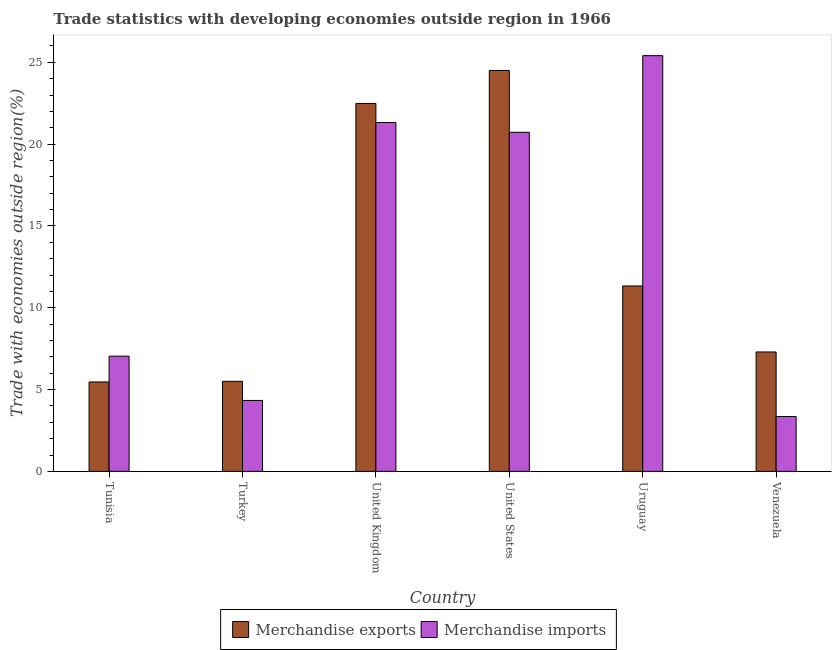How many groups of bars are there?
Your answer should be very brief. 6. How many bars are there on the 1st tick from the left?
Your response must be concise. 2. How many bars are there on the 5th tick from the right?
Your answer should be very brief. 2. What is the label of the 5th group of bars from the left?
Offer a terse response. Uruguay. What is the merchandise imports in Uruguay?
Your answer should be compact. 25.41. Across all countries, what is the maximum merchandise imports?
Offer a very short reply. 25.41. Across all countries, what is the minimum merchandise exports?
Make the answer very short. 5.46. In which country was the merchandise imports maximum?
Offer a terse response. Uruguay. In which country was the merchandise imports minimum?
Offer a very short reply. Venezuela. What is the total merchandise imports in the graph?
Your answer should be very brief. 82.18. What is the difference between the merchandise imports in Tunisia and that in Turkey?
Keep it short and to the point. 2.71. What is the difference between the merchandise exports in United Kingdom and the merchandise imports in Tunisia?
Keep it short and to the point. 15.45. What is the average merchandise imports per country?
Make the answer very short. 13.7. What is the difference between the merchandise imports and merchandise exports in Uruguay?
Offer a very short reply. 14.08. In how many countries, is the merchandise exports greater than 9 %?
Your answer should be very brief. 3. What is the ratio of the merchandise exports in United States to that in Venezuela?
Offer a terse response. 3.36. Is the merchandise exports in Tunisia less than that in United States?
Your answer should be compact. Yes. What is the difference between the highest and the second highest merchandise imports?
Provide a short and direct response. 4.09. What is the difference between the highest and the lowest merchandise imports?
Offer a terse response. 22.06. In how many countries, is the merchandise imports greater than the average merchandise imports taken over all countries?
Offer a terse response. 3. What does the 1st bar from the right in United Kingdom represents?
Offer a terse response. Merchandise imports. Are the values on the major ticks of Y-axis written in scientific E-notation?
Offer a terse response. No. Does the graph contain any zero values?
Ensure brevity in your answer.  No. Does the graph contain grids?
Provide a succinct answer. No. How many legend labels are there?
Make the answer very short. 2. How are the legend labels stacked?
Make the answer very short. Horizontal. What is the title of the graph?
Make the answer very short. Trade statistics with developing economies outside region in 1966. What is the label or title of the X-axis?
Your answer should be very brief. Country. What is the label or title of the Y-axis?
Provide a succinct answer. Trade with economies outside region(%). What is the Trade with economies outside region(%) of Merchandise exports in Tunisia?
Keep it short and to the point. 5.46. What is the Trade with economies outside region(%) in Merchandise imports in Tunisia?
Ensure brevity in your answer.  7.04. What is the Trade with economies outside region(%) of Merchandise exports in Turkey?
Your answer should be compact. 5.5. What is the Trade with economies outside region(%) of Merchandise imports in Turkey?
Provide a succinct answer. 4.34. What is the Trade with economies outside region(%) in Merchandise exports in United Kingdom?
Make the answer very short. 22.49. What is the Trade with economies outside region(%) of Merchandise imports in United Kingdom?
Offer a terse response. 21.32. What is the Trade with economies outside region(%) in Merchandise exports in United States?
Your answer should be compact. 24.51. What is the Trade with economies outside region(%) in Merchandise imports in United States?
Give a very brief answer. 20.73. What is the Trade with economies outside region(%) of Merchandise exports in Uruguay?
Offer a terse response. 11.33. What is the Trade with economies outside region(%) in Merchandise imports in Uruguay?
Your answer should be compact. 25.41. What is the Trade with economies outside region(%) of Merchandise exports in Venezuela?
Your answer should be very brief. 7.3. What is the Trade with economies outside region(%) in Merchandise imports in Venezuela?
Ensure brevity in your answer.  3.35. Across all countries, what is the maximum Trade with economies outside region(%) in Merchandise exports?
Your response must be concise. 24.51. Across all countries, what is the maximum Trade with economies outside region(%) in Merchandise imports?
Offer a very short reply. 25.41. Across all countries, what is the minimum Trade with economies outside region(%) in Merchandise exports?
Your answer should be compact. 5.46. Across all countries, what is the minimum Trade with economies outside region(%) in Merchandise imports?
Offer a terse response. 3.35. What is the total Trade with economies outside region(%) in Merchandise exports in the graph?
Give a very brief answer. 76.59. What is the total Trade with economies outside region(%) in Merchandise imports in the graph?
Keep it short and to the point. 82.18. What is the difference between the Trade with economies outside region(%) of Merchandise exports in Tunisia and that in Turkey?
Offer a terse response. -0.04. What is the difference between the Trade with economies outside region(%) in Merchandise imports in Tunisia and that in Turkey?
Your answer should be very brief. 2.71. What is the difference between the Trade with economies outside region(%) in Merchandise exports in Tunisia and that in United Kingdom?
Give a very brief answer. -17.02. What is the difference between the Trade with economies outside region(%) in Merchandise imports in Tunisia and that in United Kingdom?
Provide a short and direct response. -14.28. What is the difference between the Trade with economies outside region(%) of Merchandise exports in Tunisia and that in United States?
Provide a short and direct response. -19.04. What is the difference between the Trade with economies outside region(%) in Merchandise imports in Tunisia and that in United States?
Ensure brevity in your answer.  -13.68. What is the difference between the Trade with economies outside region(%) in Merchandise exports in Tunisia and that in Uruguay?
Provide a short and direct response. -5.87. What is the difference between the Trade with economies outside region(%) of Merchandise imports in Tunisia and that in Uruguay?
Give a very brief answer. -18.37. What is the difference between the Trade with economies outside region(%) in Merchandise exports in Tunisia and that in Venezuela?
Offer a terse response. -1.83. What is the difference between the Trade with economies outside region(%) of Merchandise imports in Tunisia and that in Venezuela?
Keep it short and to the point. 3.69. What is the difference between the Trade with economies outside region(%) of Merchandise exports in Turkey and that in United Kingdom?
Give a very brief answer. -16.99. What is the difference between the Trade with economies outside region(%) of Merchandise imports in Turkey and that in United Kingdom?
Keep it short and to the point. -16.99. What is the difference between the Trade with economies outside region(%) of Merchandise exports in Turkey and that in United States?
Keep it short and to the point. -19. What is the difference between the Trade with economies outside region(%) of Merchandise imports in Turkey and that in United States?
Keep it short and to the point. -16.39. What is the difference between the Trade with economies outside region(%) in Merchandise exports in Turkey and that in Uruguay?
Your answer should be very brief. -5.83. What is the difference between the Trade with economies outside region(%) of Merchandise imports in Turkey and that in Uruguay?
Offer a very short reply. -21.07. What is the difference between the Trade with economies outside region(%) of Merchandise exports in Turkey and that in Venezuela?
Provide a succinct answer. -1.79. What is the difference between the Trade with economies outside region(%) in Merchandise imports in Turkey and that in Venezuela?
Make the answer very short. 0.98. What is the difference between the Trade with economies outside region(%) of Merchandise exports in United Kingdom and that in United States?
Your answer should be compact. -2.02. What is the difference between the Trade with economies outside region(%) in Merchandise imports in United Kingdom and that in United States?
Make the answer very short. 0.6. What is the difference between the Trade with economies outside region(%) of Merchandise exports in United Kingdom and that in Uruguay?
Ensure brevity in your answer.  11.16. What is the difference between the Trade with economies outside region(%) of Merchandise imports in United Kingdom and that in Uruguay?
Your answer should be very brief. -4.09. What is the difference between the Trade with economies outside region(%) of Merchandise exports in United Kingdom and that in Venezuela?
Your answer should be compact. 15.19. What is the difference between the Trade with economies outside region(%) in Merchandise imports in United Kingdom and that in Venezuela?
Ensure brevity in your answer.  17.97. What is the difference between the Trade with economies outside region(%) of Merchandise exports in United States and that in Uruguay?
Ensure brevity in your answer.  13.17. What is the difference between the Trade with economies outside region(%) of Merchandise imports in United States and that in Uruguay?
Provide a succinct answer. -4.68. What is the difference between the Trade with economies outside region(%) in Merchandise exports in United States and that in Venezuela?
Give a very brief answer. 17.21. What is the difference between the Trade with economies outside region(%) of Merchandise imports in United States and that in Venezuela?
Offer a terse response. 17.37. What is the difference between the Trade with economies outside region(%) of Merchandise exports in Uruguay and that in Venezuela?
Keep it short and to the point. 4.03. What is the difference between the Trade with economies outside region(%) in Merchandise imports in Uruguay and that in Venezuela?
Your answer should be very brief. 22.06. What is the difference between the Trade with economies outside region(%) of Merchandise exports in Tunisia and the Trade with economies outside region(%) of Merchandise imports in Turkey?
Offer a terse response. 1.13. What is the difference between the Trade with economies outside region(%) of Merchandise exports in Tunisia and the Trade with economies outside region(%) of Merchandise imports in United Kingdom?
Make the answer very short. -15.86. What is the difference between the Trade with economies outside region(%) of Merchandise exports in Tunisia and the Trade with economies outside region(%) of Merchandise imports in United States?
Offer a very short reply. -15.26. What is the difference between the Trade with economies outside region(%) in Merchandise exports in Tunisia and the Trade with economies outside region(%) in Merchandise imports in Uruguay?
Your answer should be compact. -19.94. What is the difference between the Trade with economies outside region(%) in Merchandise exports in Tunisia and the Trade with economies outside region(%) in Merchandise imports in Venezuela?
Offer a terse response. 2.11. What is the difference between the Trade with economies outside region(%) of Merchandise exports in Turkey and the Trade with economies outside region(%) of Merchandise imports in United Kingdom?
Provide a short and direct response. -15.82. What is the difference between the Trade with economies outside region(%) of Merchandise exports in Turkey and the Trade with economies outside region(%) of Merchandise imports in United States?
Offer a terse response. -15.22. What is the difference between the Trade with economies outside region(%) in Merchandise exports in Turkey and the Trade with economies outside region(%) in Merchandise imports in Uruguay?
Your response must be concise. -19.91. What is the difference between the Trade with economies outside region(%) in Merchandise exports in Turkey and the Trade with economies outside region(%) in Merchandise imports in Venezuela?
Keep it short and to the point. 2.15. What is the difference between the Trade with economies outside region(%) in Merchandise exports in United Kingdom and the Trade with economies outside region(%) in Merchandise imports in United States?
Your answer should be compact. 1.76. What is the difference between the Trade with economies outside region(%) in Merchandise exports in United Kingdom and the Trade with economies outside region(%) in Merchandise imports in Uruguay?
Provide a short and direct response. -2.92. What is the difference between the Trade with economies outside region(%) of Merchandise exports in United Kingdom and the Trade with economies outside region(%) of Merchandise imports in Venezuela?
Your answer should be very brief. 19.14. What is the difference between the Trade with economies outside region(%) in Merchandise exports in United States and the Trade with economies outside region(%) in Merchandise imports in Uruguay?
Keep it short and to the point. -0.9. What is the difference between the Trade with economies outside region(%) of Merchandise exports in United States and the Trade with economies outside region(%) of Merchandise imports in Venezuela?
Make the answer very short. 21.16. What is the difference between the Trade with economies outside region(%) in Merchandise exports in Uruguay and the Trade with economies outside region(%) in Merchandise imports in Venezuela?
Keep it short and to the point. 7.98. What is the average Trade with economies outside region(%) in Merchandise exports per country?
Ensure brevity in your answer.  12.77. What is the average Trade with economies outside region(%) of Merchandise imports per country?
Ensure brevity in your answer.  13.7. What is the difference between the Trade with economies outside region(%) in Merchandise exports and Trade with economies outside region(%) in Merchandise imports in Tunisia?
Provide a succinct answer. -1.58. What is the difference between the Trade with economies outside region(%) in Merchandise exports and Trade with economies outside region(%) in Merchandise imports in Turkey?
Offer a terse response. 1.17. What is the difference between the Trade with economies outside region(%) of Merchandise exports and Trade with economies outside region(%) of Merchandise imports in United Kingdom?
Provide a succinct answer. 1.17. What is the difference between the Trade with economies outside region(%) in Merchandise exports and Trade with economies outside region(%) in Merchandise imports in United States?
Offer a very short reply. 3.78. What is the difference between the Trade with economies outside region(%) in Merchandise exports and Trade with economies outside region(%) in Merchandise imports in Uruguay?
Offer a terse response. -14.08. What is the difference between the Trade with economies outside region(%) in Merchandise exports and Trade with economies outside region(%) in Merchandise imports in Venezuela?
Keep it short and to the point. 3.95. What is the ratio of the Trade with economies outside region(%) of Merchandise exports in Tunisia to that in Turkey?
Keep it short and to the point. 0.99. What is the ratio of the Trade with economies outside region(%) of Merchandise imports in Tunisia to that in Turkey?
Your answer should be compact. 1.62. What is the ratio of the Trade with economies outside region(%) of Merchandise exports in Tunisia to that in United Kingdom?
Offer a terse response. 0.24. What is the ratio of the Trade with economies outside region(%) in Merchandise imports in Tunisia to that in United Kingdom?
Provide a short and direct response. 0.33. What is the ratio of the Trade with economies outside region(%) in Merchandise exports in Tunisia to that in United States?
Ensure brevity in your answer.  0.22. What is the ratio of the Trade with economies outside region(%) in Merchandise imports in Tunisia to that in United States?
Provide a succinct answer. 0.34. What is the ratio of the Trade with economies outside region(%) of Merchandise exports in Tunisia to that in Uruguay?
Provide a short and direct response. 0.48. What is the ratio of the Trade with economies outside region(%) of Merchandise imports in Tunisia to that in Uruguay?
Provide a succinct answer. 0.28. What is the ratio of the Trade with economies outside region(%) of Merchandise exports in Tunisia to that in Venezuela?
Your answer should be compact. 0.75. What is the ratio of the Trade with economies outside region(%) in Merchandise imports in Tunisia to that in Venezuela?
Give a very brief answer. 2.1. What is the ratio of the Trade with economies outside region(%) of Merchandise exports in Turkey to that in United Kingdom?
Give a very brief answer. 0.24. What is the ratio of the Trade with economies outside region(%) of Merchandise imports in Turkey to that in United Kingdom?
Ensure brevity in your answer.  0.2. What is the ratio of the Trade with economies outside region(%) in Merchandise exports in Turkey to that in United States?
Offer a terse response. 0.22. What is the ratio of the Trade with economies outside region(%) in Merchandise imports in Turkey to that in United States?
Offer a very short reply. 0.21. What is the ratio of the Trade with economies outside region(%) of Merchandise exports in Turkey to that in Uruguay?
Ensure brevity in your answer.  0.49. What is the ratio of the Trade with economies outside region(%) in Merchandise imports in Turkey to that in Uruguay?
Offer a very short reply. 0.17. What is the ratio of the Trade with economies outside region(%) of Merchandise exports in Turkey to that in Venezuela?
Ensure brevity in your answer.  0.75. What is the ratio of the Trade with economies outside region(%) of Merchandise imports in Turkey to that in Venezuela?
Provide a short and direct response. 1.29. What is the ratio of the Trade with economies outside region(%) of Merchandise exports in United Kingdom to that in United States?
Ensure brevity in your answer.  0.92. What is the ratio of the Trade with economies outside region(%) in Merchandise imports in United Kingdom to that in United States?
Offer a very short reply. 1.03. What is the ratio of the Trade with economies outside region(%) of Merchandise exports in United Kingdom to that in Uruguay?
Your answer should be very brief. 1.98. What is the ratio of the Trade with economies outside region(%) of Merchandise imports in United Kingdom to that in Uruguay?
Make the answer very short. 0.84. What is the ratio of the Trade with economies outside region(%) of Merchandise exports in United Kingdom to that in Venezuela?
Keep it short and to the point. 3.08. What is the ratio of the Trade with economies outside region(%) in Merchandise imports in United Kingdom to that in Venezuela?
Make the answer very short. 6.36. What is the ratio of the Trade with economies outside region(%) in Merchandise exports in United States to that in Uruguay?
Keep it short and to the point. 2.16. What is the ratio of the Trade with economies outside region(%) of Merchandise imports in United States to that in Uruguay?
Offer a very short reply. 0.82. What is the ratio of the Trade with economies outside region(%) in Merchandise exports in United States to that in Venezuela?
Make the answer very short. 3.36. What is the ratio of the Trade with economies outside region(%) of Merchandise imports in United States to that in Venezuela?
Offer a very short reply. 6.19. What is the ratio of the Trade with economies outside region(%) in Merchandise exports in Uruguay to that in Venezuela?
Ensure brevity in your answer.  1.55. What is the ratio of the Trade with economies outside region(%) in Merchandise imports in Uruguay to that in Venezuela?
Ensure brevity in your answer.  7.58. What is the difference between the highest and the second highest Trade with economies outside region(%) in Merchandise exports?
Your answer should be very brief. 2.02. What is the difference between the highest and the second highest Trade with economies outside region(%) in Merchandise imports?
Make the answer very short. 4.09. What is the difference between the highest and the lowest Trade with economies outside region(%) in Merchandise exports?
Offer a very short reply. 19.04. What is the difference between the highest and the lowest Trade with economies outside region(%) of Merchandise imports?
Your answer should be compact. 22.06. 